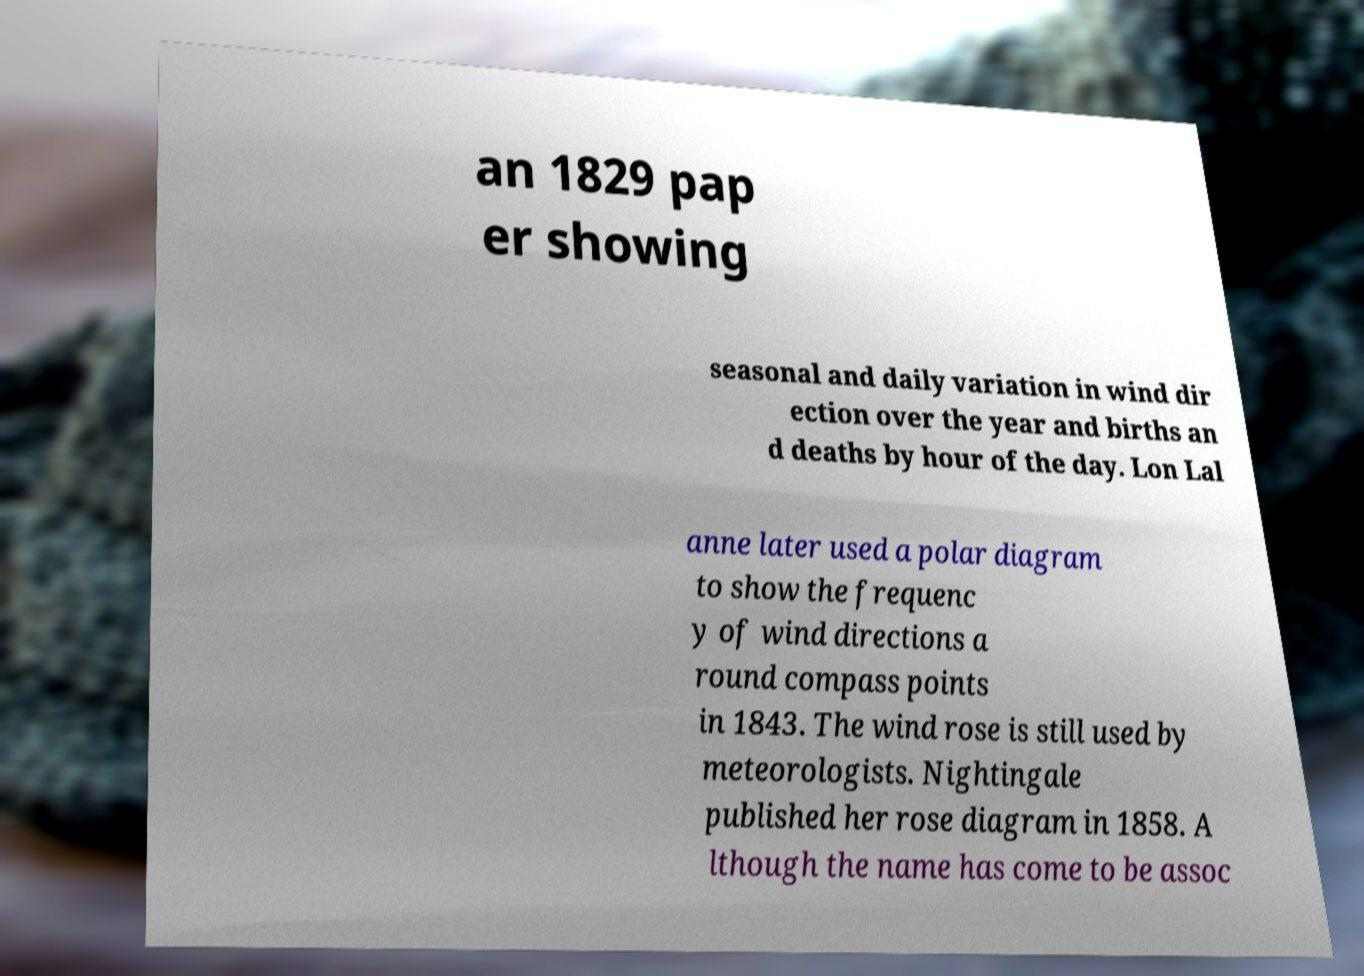Can you accurately transcribe the text from the provided image for me? an 1829 pap er showing seasonal and daily variation in wind dir ection over the year and births an d deaths by hour of the day. Lon Lal anne later used a polar diagram to show the frequenc y of wind directions a round compass points in 1843. The wind rose is still used by meteorologists. Nightingale published her rose diagram in 1858. A lthough the name has come to be assoc 